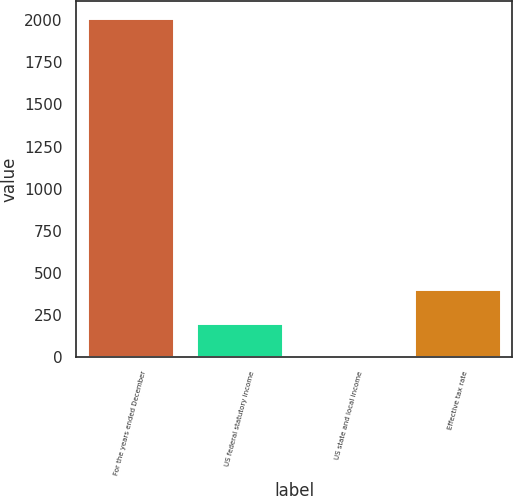<chart> <loc_0><loc_0><loc_500><loc_500><bar_chart><fcel>For the years ended December<fcel>US federal statutory income<fcel>US state and local income<fcel>Effective tax rate<nl><fcel>2014<fcel>203.65<fcel>2.5<fcel>404.8<nl></chart> 